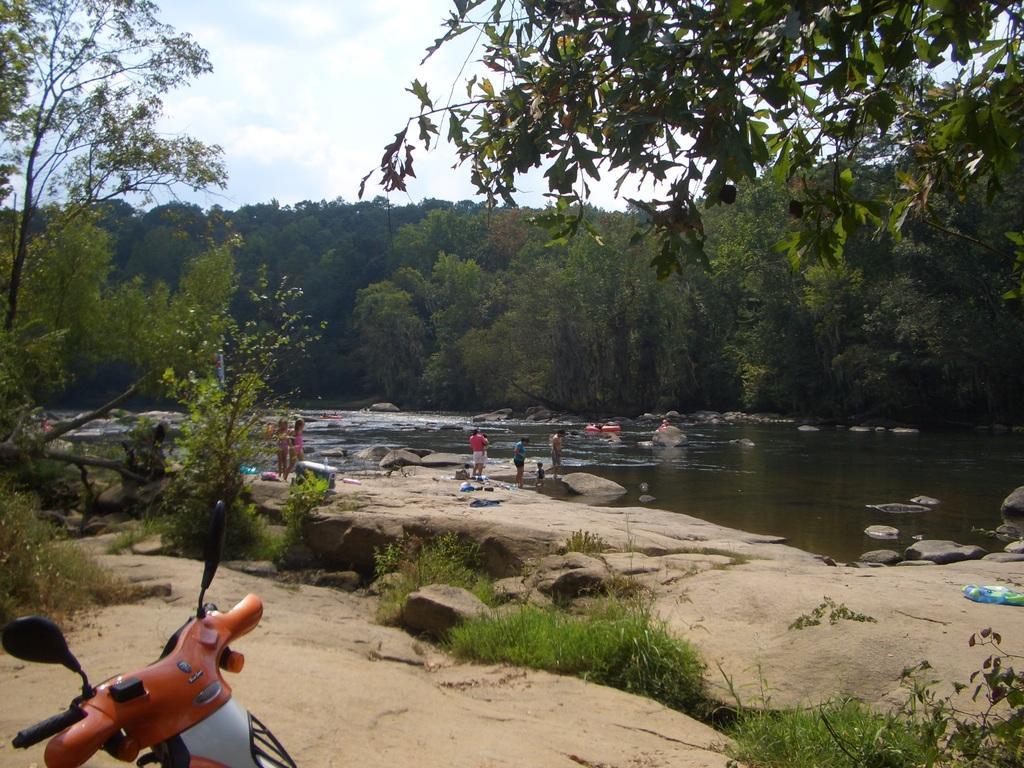Please provide a concise description of this image. In this image we can see the water. And we can see the people. And we can see the stones. And we can see the grass, trees and plants. And we can see the clouds in the sky. And we can see one vehicle. 